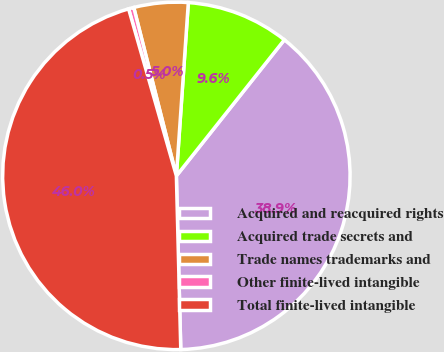Convert chart. <chart><loc_0><loc_0><loc_500><loc_500><pie_chart><fcel>Acquired and reacquired rights<fcel>Acquired trade secrets and<fcel>Trade names trademarks and<fcel>Other finite-lived intangible<fcel>Total finite-lived intangible<nl><fcel>38.92%<fcel>9.58%<fcel>5.04%<fcel>0.49%<fcel>45.97%<nl></chart> 